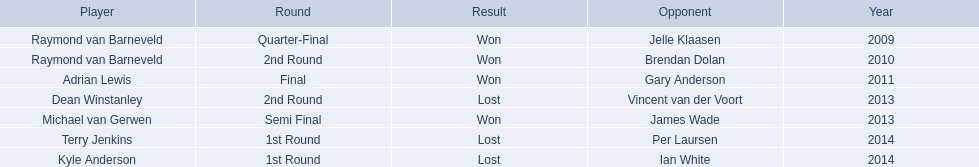Who were all the players? Raymond van Barneveld, Raymond van Barneveld, Adrian Lewis, Dean Winstanley, Michael van Gerwen, Terry Jenkins, Kyle Anderson. Which of these played in 2014? Terry Jenkins, Kyle Anderson. Who were their opponents? Per Laursen, Ian White. Which of these beat terry jenkins? Per Laursen. 